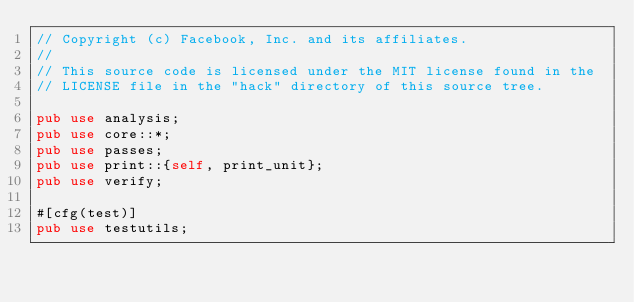Convert code to text. <code><loc_0><loc_0><loc_500><loc_500><_Rust_>// Copyright (c) Facebook, Inc. and its affiliates.
//
// This source code is licensed under the MIT license found in the
// LICENSE file in the "hack" directory of this source tree.

pub use analysis;
pub use core::*;
pub use passes;
pub use print::{self, print_unit};
pub use verify;

#[cfg(test)]
pub use testutils;
</code> 